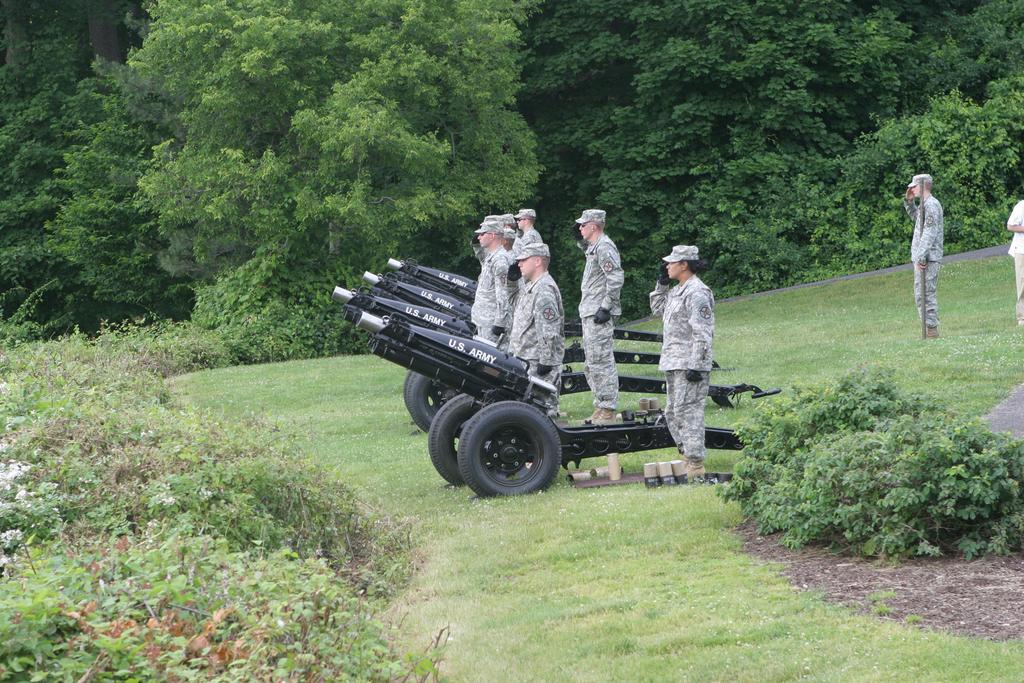Can you describe this image briefly? In this picture, we see men in the uniform are standing. They are saluting. Beside them, we see machine guns. At the bottom of the picture, we see grass. On the either side of the picture, we see shrubs and trees. The man on the right side is holding something in his hand. There are trees in the background. 